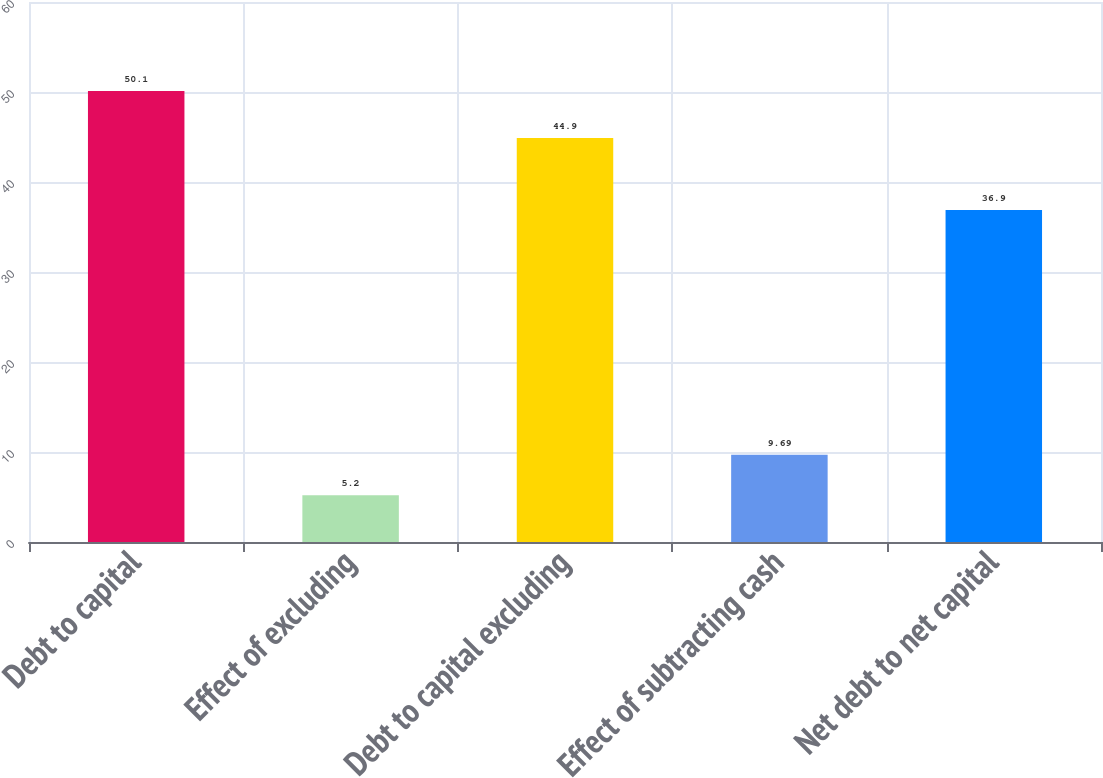<chart> <loc_0><loc_0><loc_500><loc_500><bar_chart><fcel>Debt to capital<fcel>Effect of excluding<fcel>Debt to capital excluding<fcel>Effect of subtracting cash<fcel>Net debt to net capital<nl><fcel>50.1<fcel>5.2<fcel>44.9<fcel>9.69<fcel>36.9<nl></chart> 